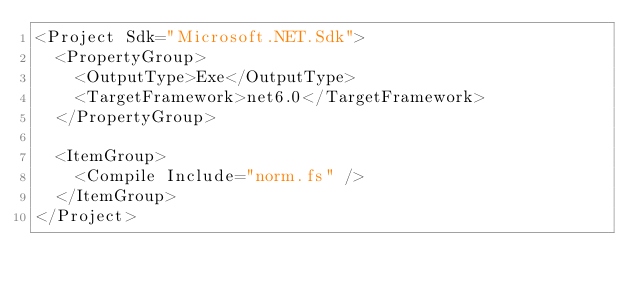<code> <loc_0><loc_0><loc_500><loc_500><_XML_><Project Sdk="Microsoft.NET.Sdk">
  <PropertyGroup>
    <OutputType>Exe</OutputType>
    <TargetFramework>net6.0</TargetFramework>
  </PropertyGroup>

  <ItemGroup>
    <Compile Include="norm.fs" />
  </ItemGroup>
</Project></code> 